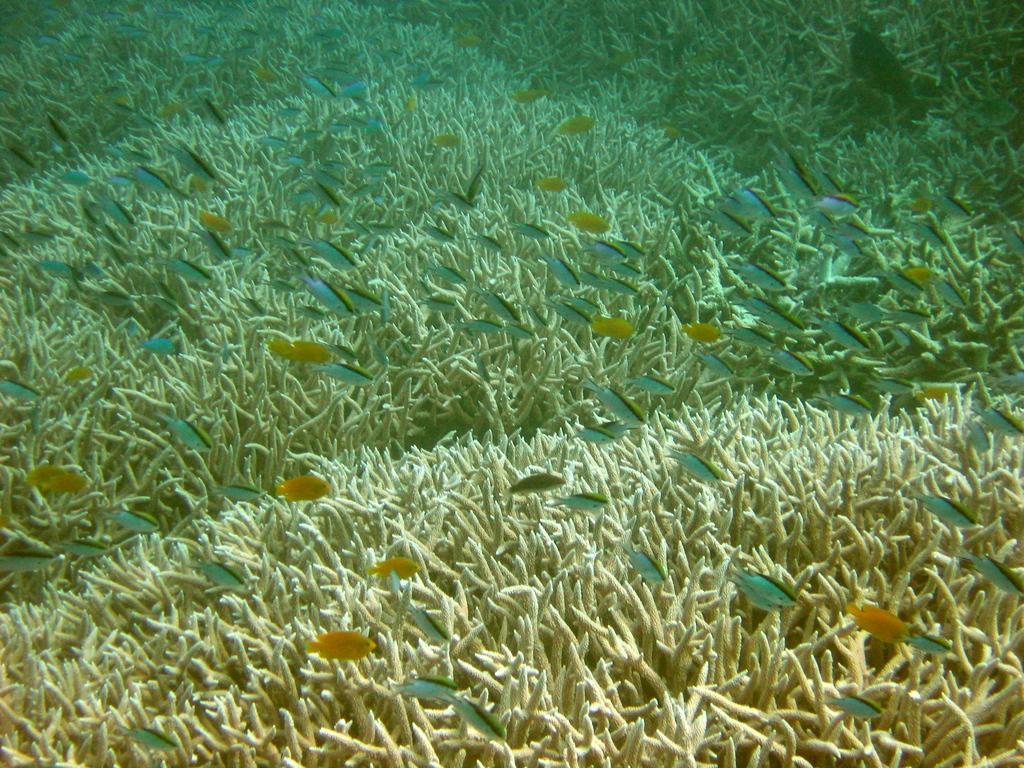Can you describe this image briefly? In this image we can see few fishes and aquatic plants underwater. 